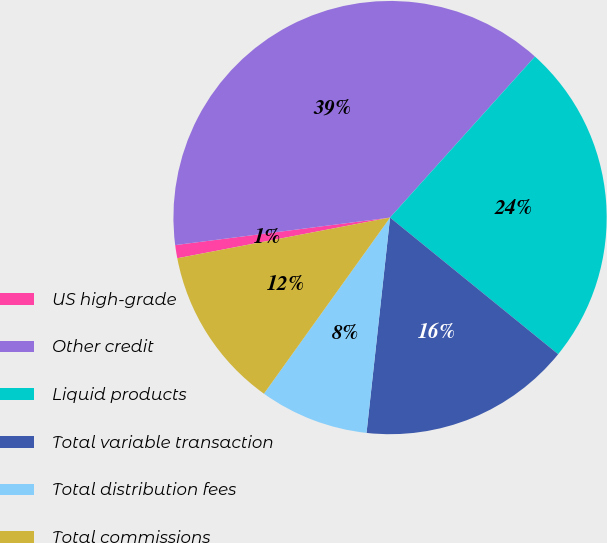Convert chart. <chart><loc_0><loc_0><loc_500><loc_500><pie_chart><fcel>US high-grade<fcel>Other credit<fcel>Liquid products<fcel>Total variable transaction<fcel>Total distribution fees<fcel>Total commissions<nl><fcel>0.98%<fcel>38.69%<fcel>24.2%<fcel>15.87%<fcel>8.16%<fcel>12.1%<nl></chart> 